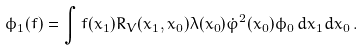<formula> <loc_0><loc_0><loc_500><loc_500>\phi _ { 1 } ( f ) = \int f ( x _ { 1 } ) R _ { V } ( x _ { 1 } , x _ { 0 } ) \lambda ( x _ { 0 } ) \dot { \varphi } ^ { 2 } ( x _ { 0 } ) \phi _ { 0 } \, d x _ { 1 } d x _ { 0 } \, .</formula> 